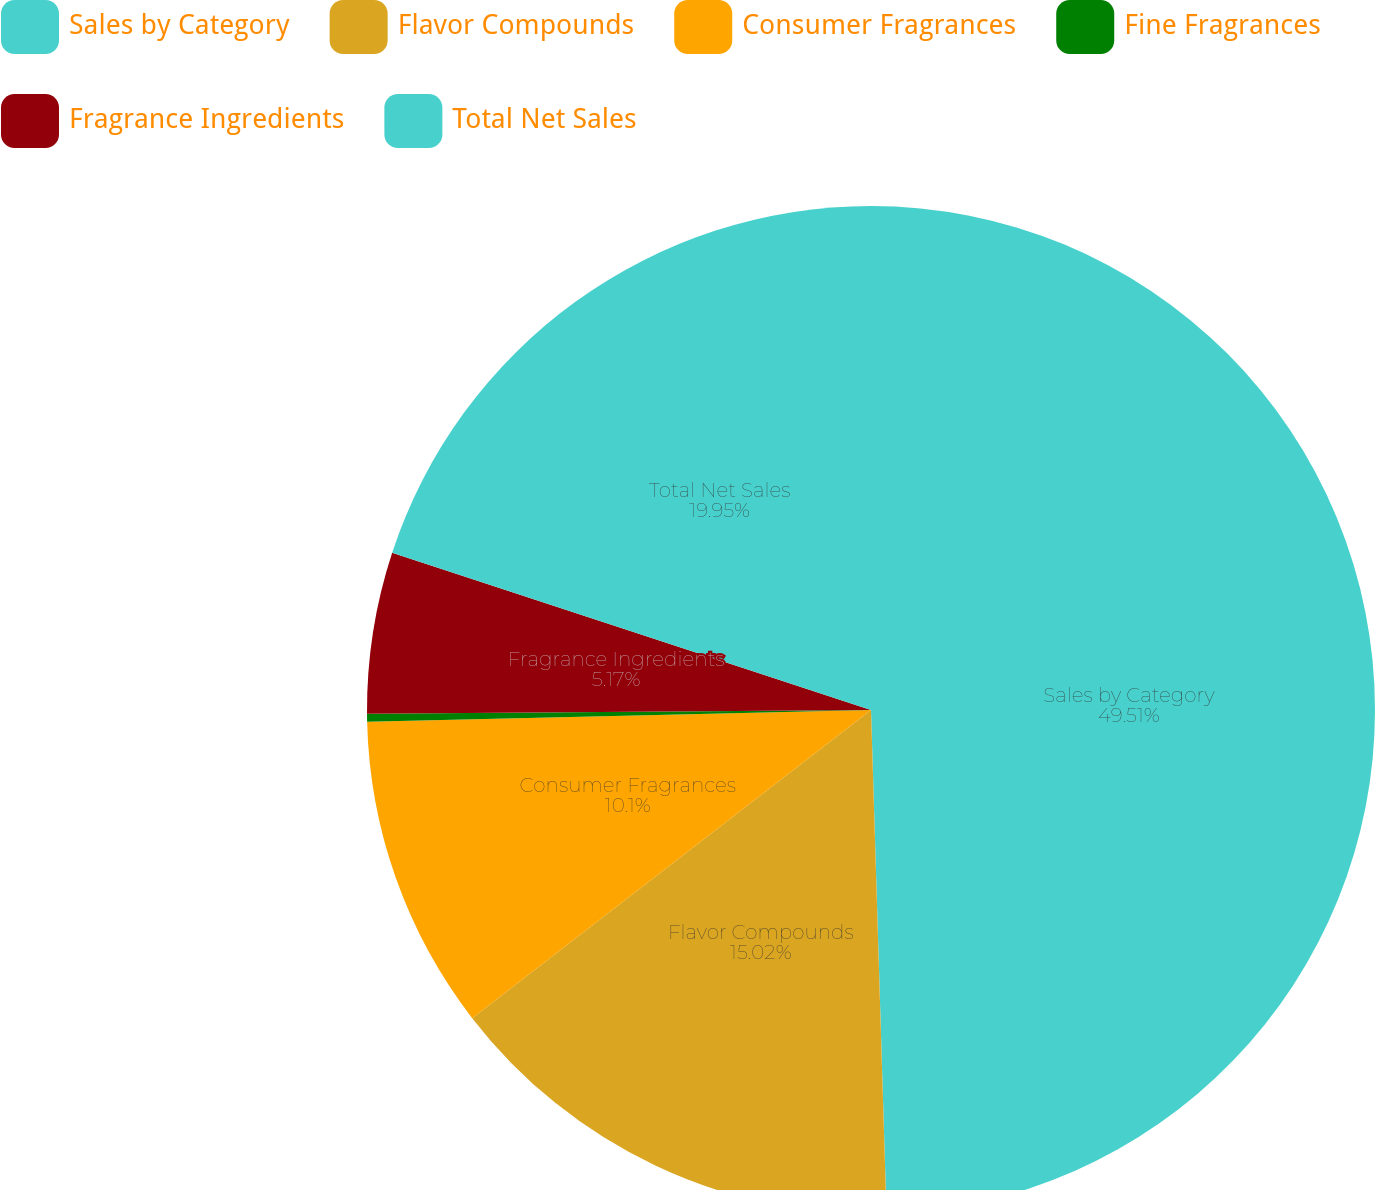Convert chart. <chart><loc_0><loc_0><loc_500><loc_500><pie_chart><fcel>Sales by Category<fcel>Flavor Compounds<fcel>Consumer Fragrances<fcel>Fine Fragrances<fcel>Fragrance Ingredients<fcel>Total Net Sales<nl><fcel>49.51%<fcel>15.02%<fcel>10.1%<fcel>0.25%<fcel>5.17%<fcel>19.95%<nl></chart> 